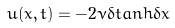Convert formula to latex. <formula><loc_0><loc_0><loc_500><loc_500>u ( x , t ) = - 2 \nu \delta t a n h \delta x</formula> 